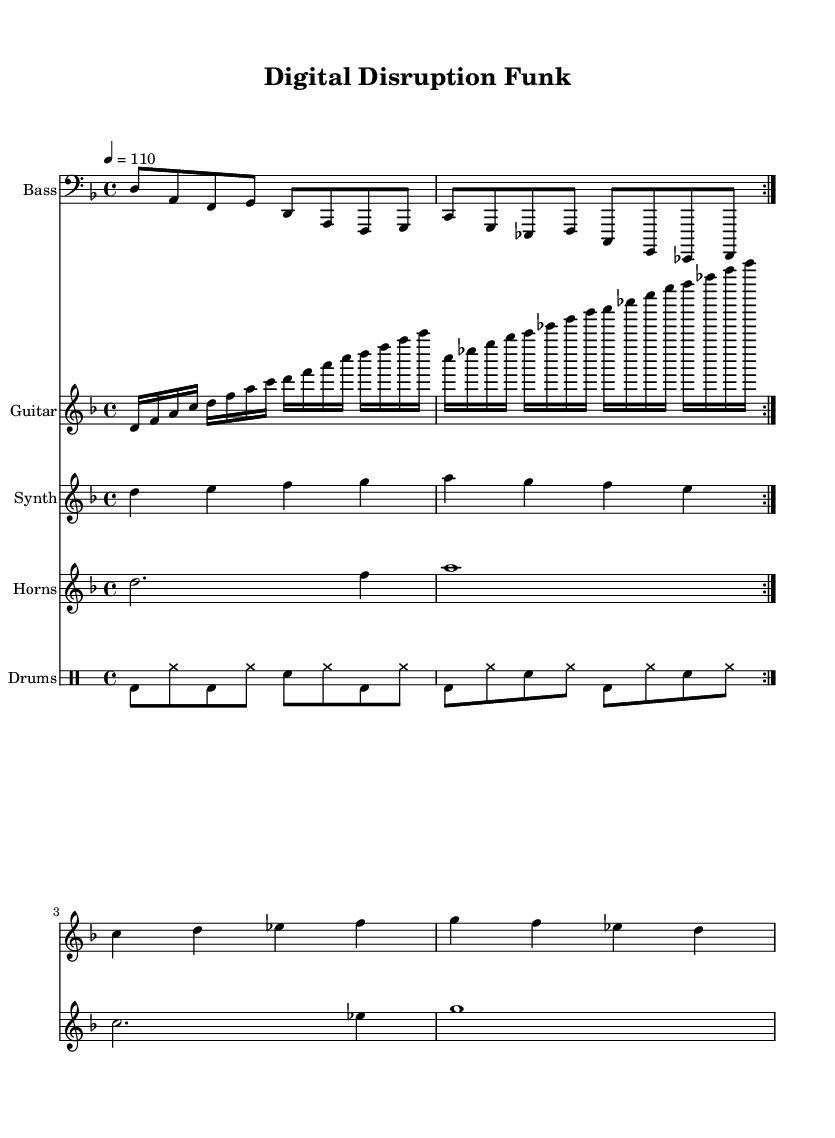What is the key signature of this music? The key signature is D minor, indicated by one flat (B flat) on the left side of the staff.
Answer: D minor What is the time signature of this music? The time signature is 4/4, shown at the beginning of the score with a "4" over another "4." This means there are four beats in each measure and the quarter note gets one beat.
Answer: 4/4 What is the tempo marking in the sheet music? The tempo marking is given as "4 = 110," indicating that there are 110 quarter note beats per minute.
Answer: 110 How many measures are in the bass line section? The bass line is repeated for two sections, with each section containing four measures, totaling eight measures overall.
Answer: 8 What instruments are included in this funk piece? The score includes four instruments: Bass, Guitar, Synth, and Horns, along with a drum section for rhythm.
Answer: Bass, Guitar, Synth, Horns Which rhythmic elements are emphasized in the drum part? The drum part emphasizes the bass drum and snare drum, with the bass drum occurring on beats 1 and 3 and the snare on beats 2 and 4, creating a strong backbeat typical in funk music.
Answer: Bass drum, snare drum What is the structure of the guitar riff? The guitar riff consists of two patterns, each containing four measures that are repeated, demonstrating a call-and-response style common in funk music.
Answer: Two patterns 